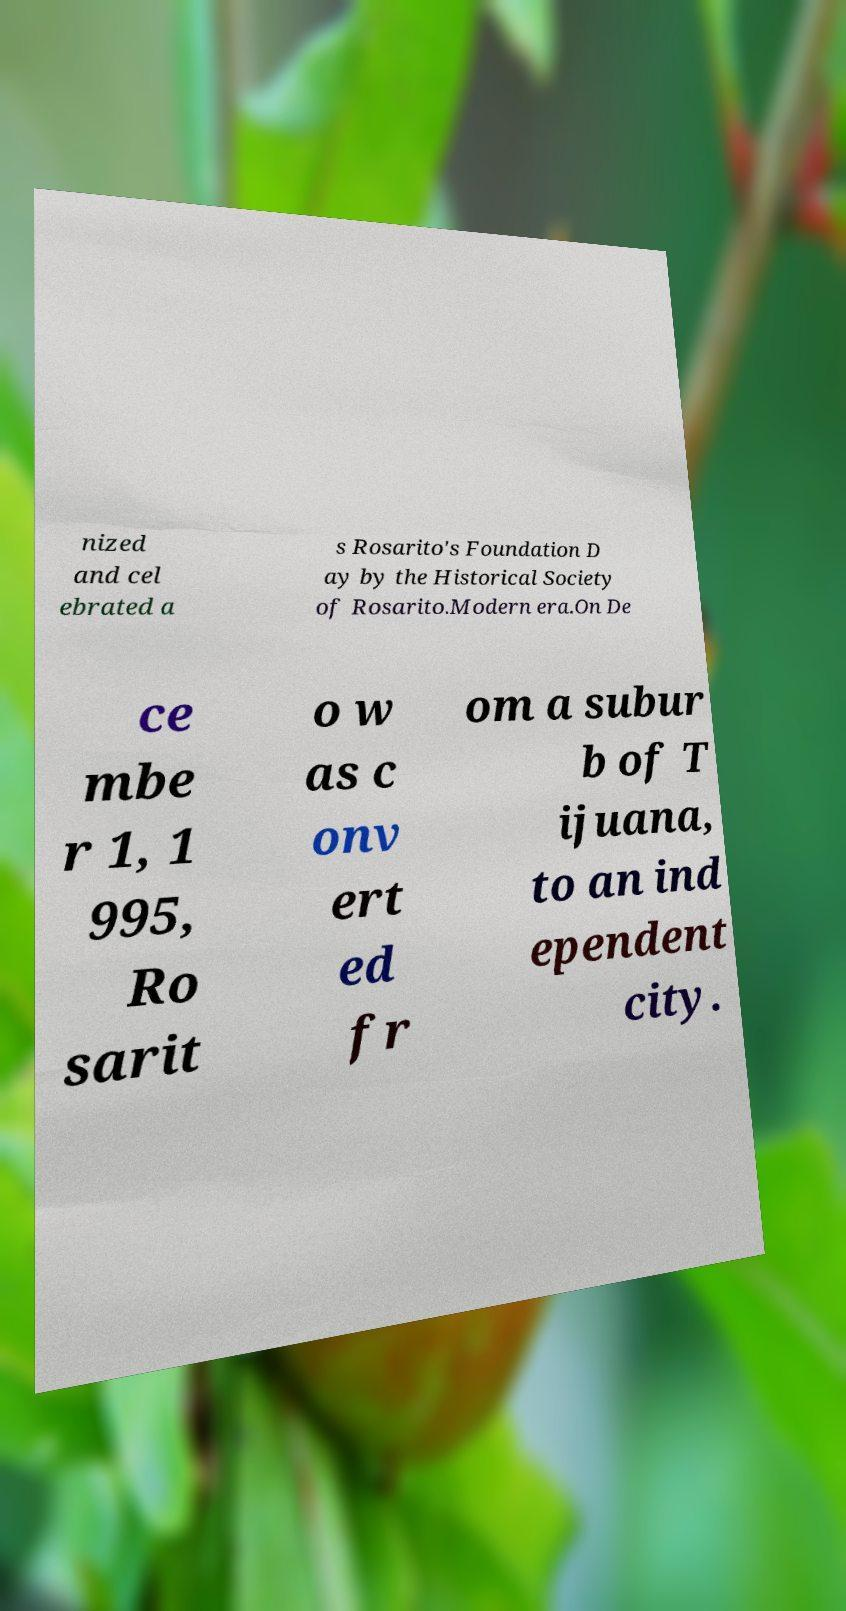Please read and relay the text visible in this image. What does it say? nized and cel ebrated a s Rosarito's Foundation D ay by the Historical Society of Rosarito.Modern era.On De ce mbe r 1, 1 995, Ro sarit o w as c onv ert ed fr om a subur b of T ijuana, to an ind ependent city. 